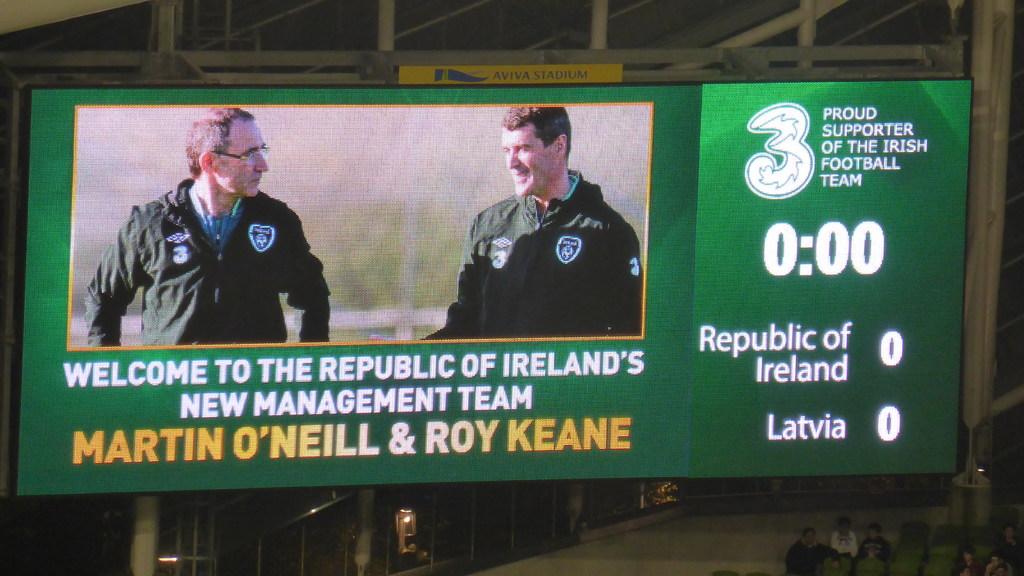What time is shown on the clock?
Your response must be concise. 0:00. 